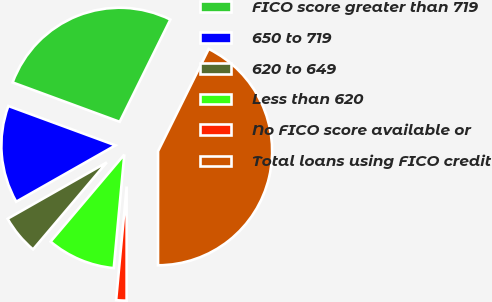Convert chart to OTSL. <chart><loc_0><loc_0><loc_500><loc_500><pie_chart><fcel>FICO score greater than 719<fcel>650 to 719<fcel>620 to 649<fcel>Less than 620<fcel>No FICO score available or<fcel>Total loans using FICO credit<nl><fcel>26.71%<fcel>13.83%<fcel>5.59%<fcel>9.71%<fcel>1.47%<fcel>42.68%<nl></chart> 